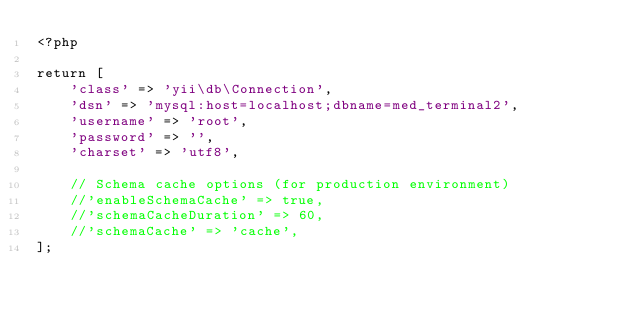<code> <loc_0><loc_0><loc_500><loc_500><_PHP_><?php

return [
    'class' => 'yii\db\Connection',
    'dsn' => 'mysql:host=localhost;dbname=med_terminal2',
    'username' => 'root',
    'password' => '',
    'charset' => 'utf8',

    // Schema cache options (for production environment)
    //'enableSchemaCache' => true,
    //'schemaCacheDuration' => 60,
    //'schemaCache' => 'cache',
];</code> 